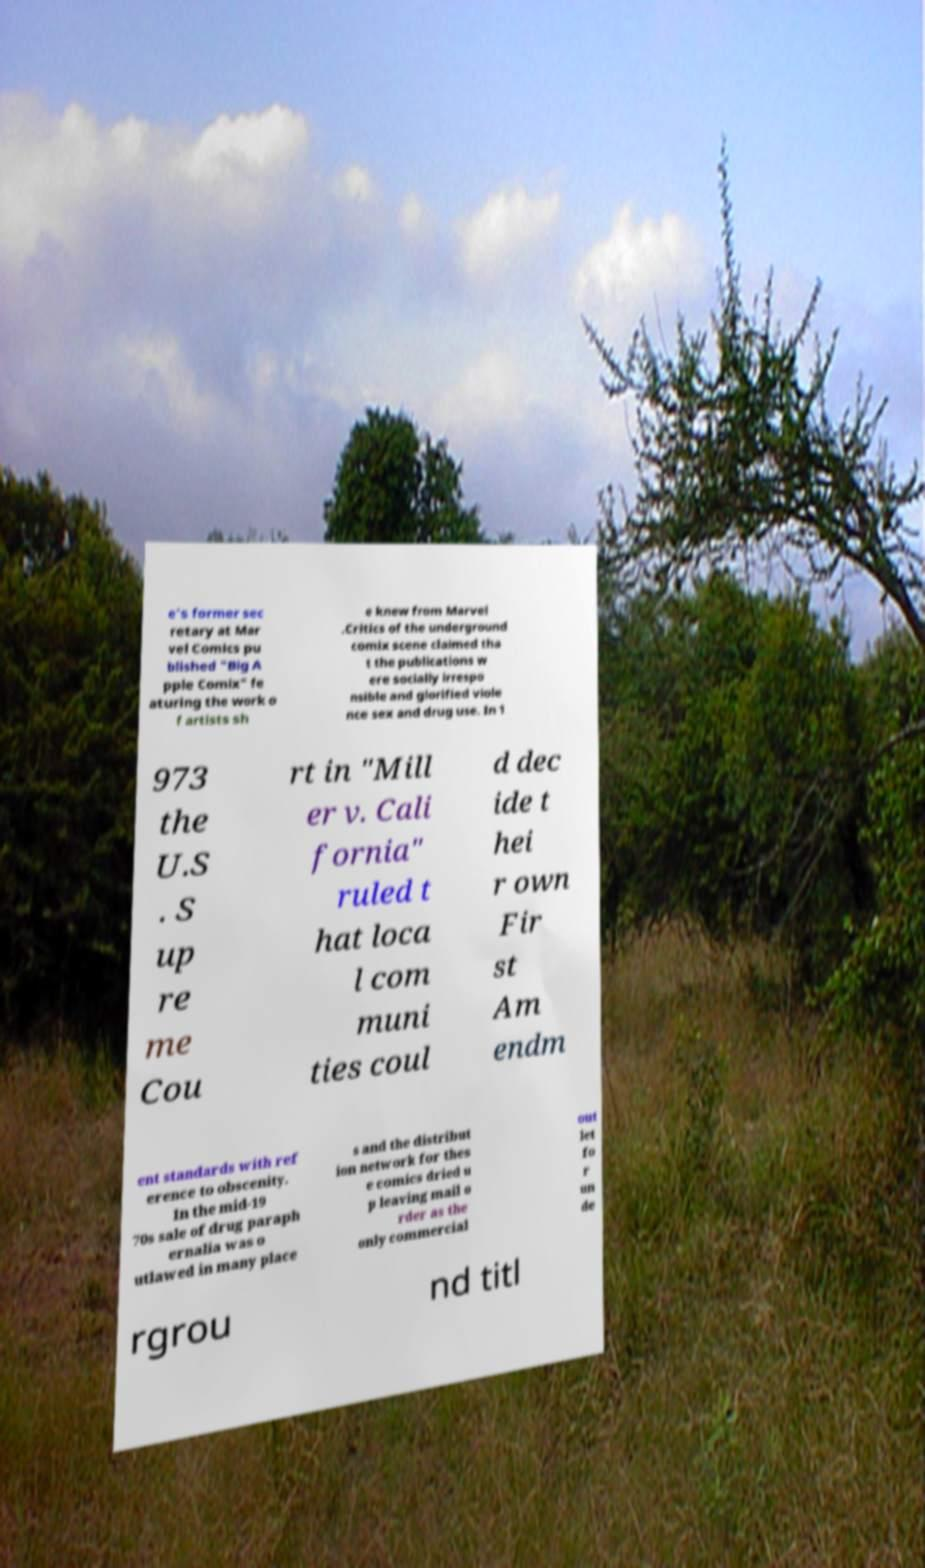For documentation purposes, I need the text within this image transcribed. Could you provide that? e's former sec retary at Mar vel Comics pu blished "Big A pple Comix" fe aturing the work o f artists sh e knew from Marvel .Critics of the underground comix scene claimed tha t the publications w ere socially irrespo nsible and glorified viole nce sex and drug use. In 1 973 the U.S . S up re me Cou rt in "Mill er v. Cali fornia" ruled t hat loca l com muni ties coul d dec ide t hei r own Fir st Am endm ent standards with ref erence to obscenity. In the mid-19 70s sale of drug paraph ernalia was o utlawed in many place s and the distribut ion network for thes e comics dried u p leaving mail o rder as the only commercial out let fo r un de rgrou nd titl 